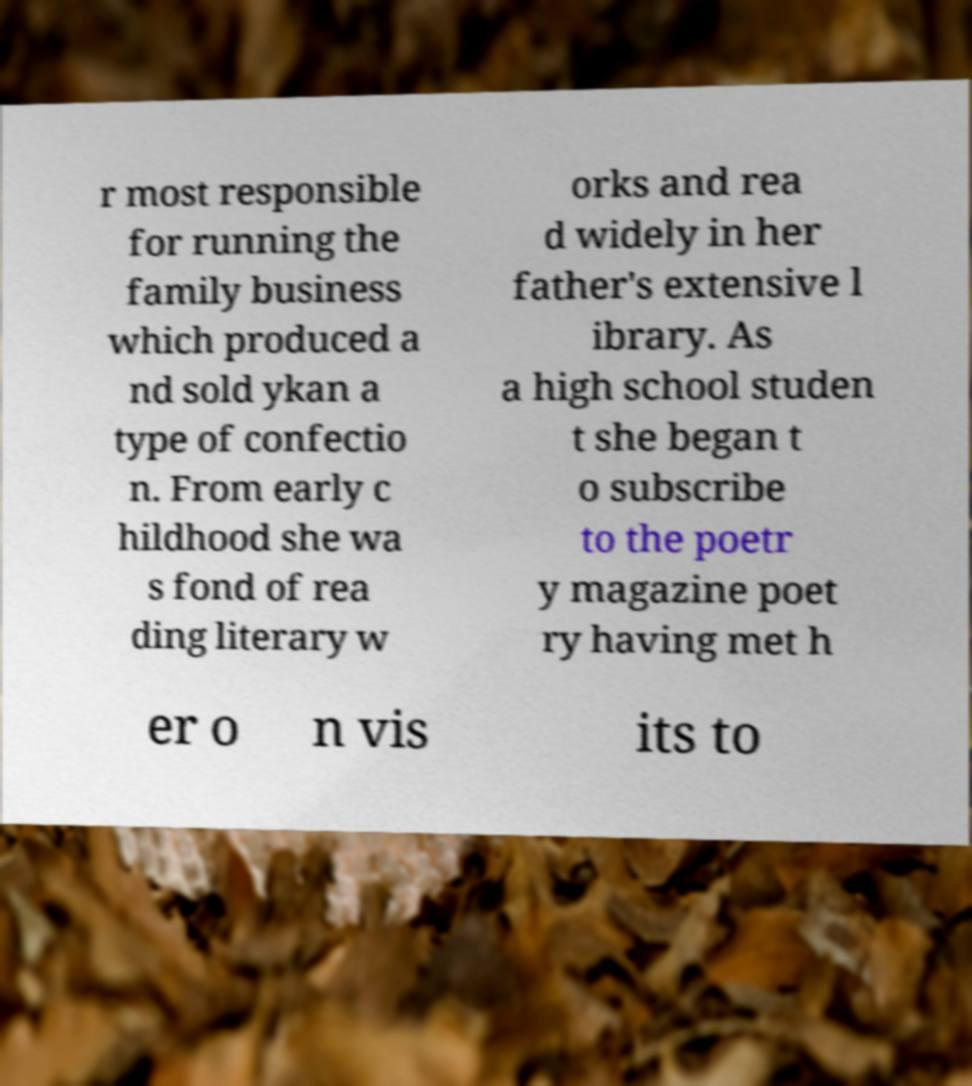Please identify and transcribe the text found in this image. r most responsible for running the family business which produced a nd sold ykan a type of confectio n. From early c hildhood she wa s fond of rea ding literary w orks and rea d widely in her father's extensive l ibrary. As a high school studen t she began t o subscribe to the poetr y magazine poet ry having met h er o n vis its to 